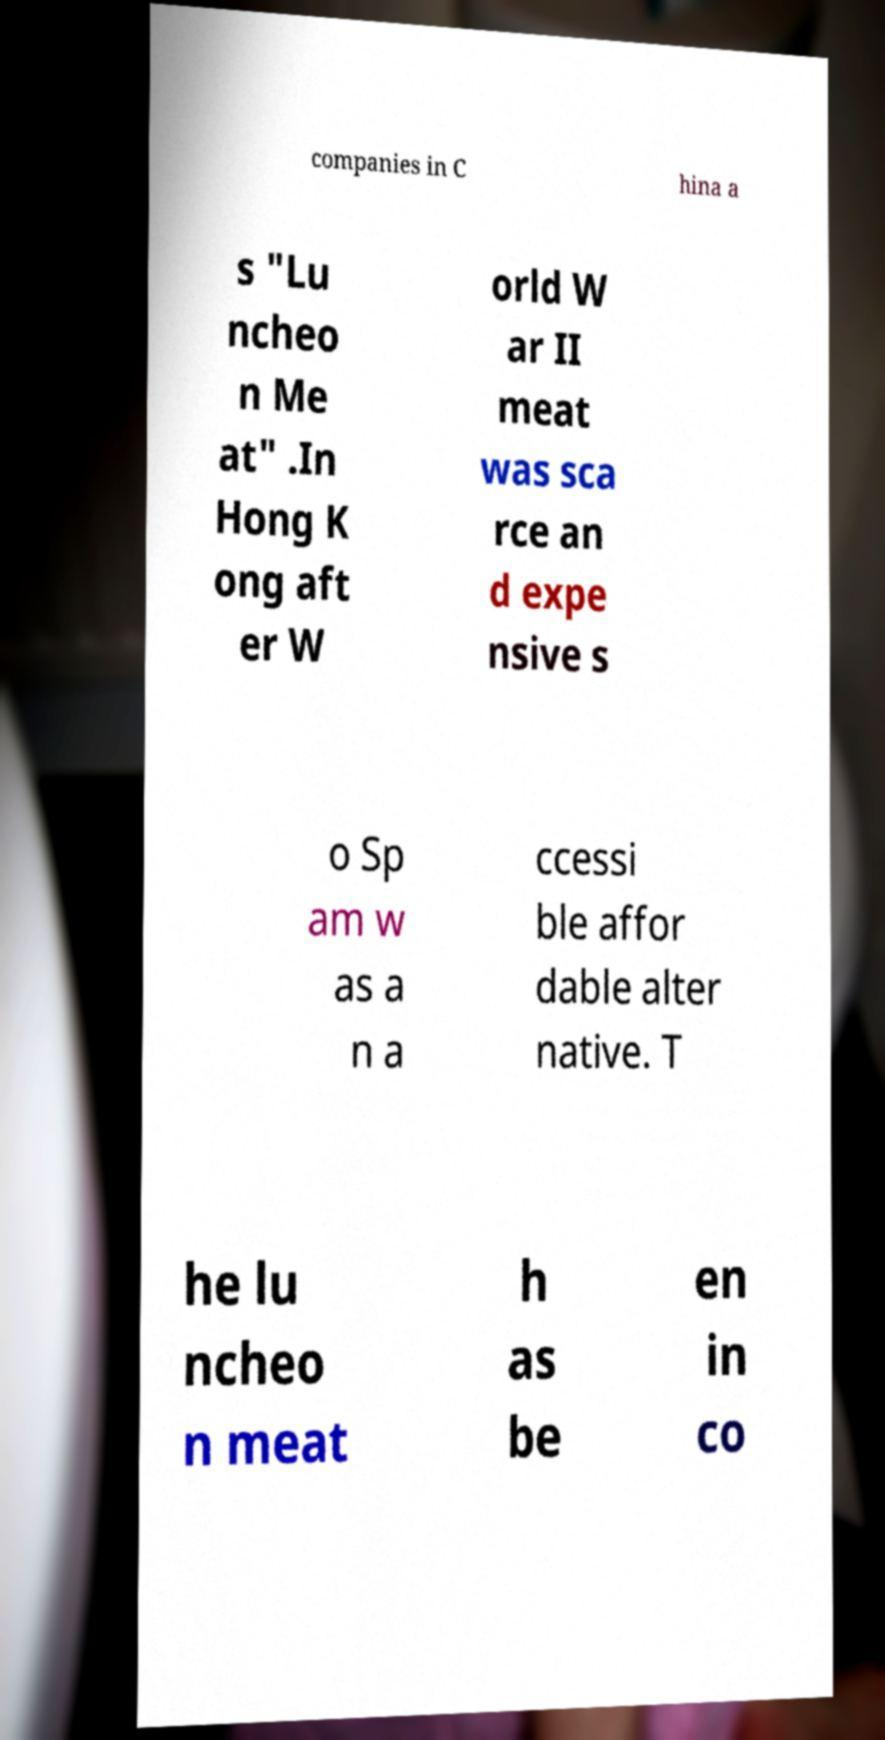I need the written content from this picture converted into text. Can you do that? companies in C hina a s "Lu ncheo n Me at" .In Hong K ong aft er W orld W ar II meat was sca rce an d expe nsive s o Sp am w as a n a ccessi ble affor dable alter native. T he lu ncheo n meat h as be en in co 